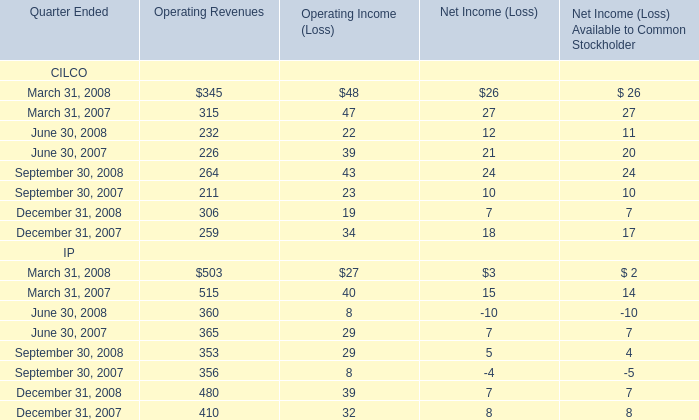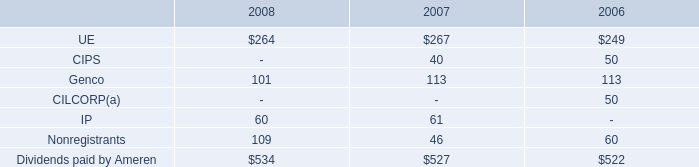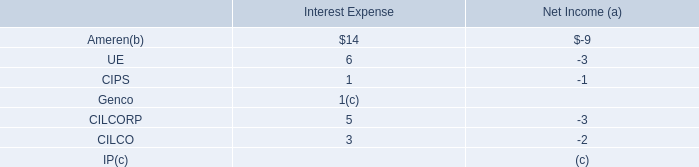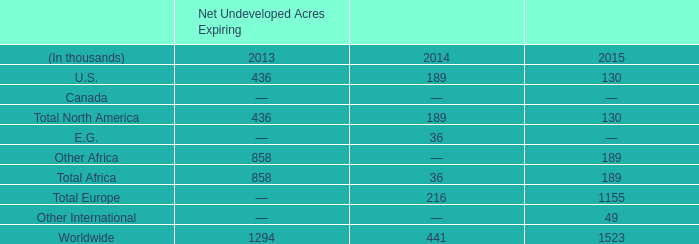What's the sum of Operating Income (Loss) of CILCO in 2008? 
Computations: (((48 + 22) + 43) + 19)
Answer: 132.0. 